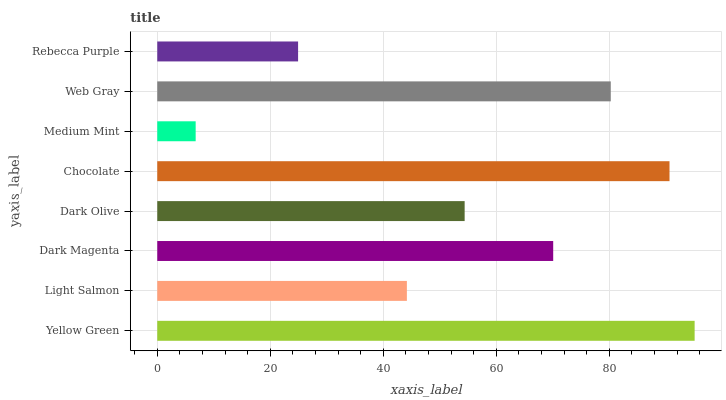Is Medium Mint the minimum?
Answer yes or no. Yes. Is Yellow Green the maximum?
Answer yes or no. Yes. Is Light Salmon the minimum?
Answer yes or no. No. Is Light Salmon the maximum?
Answer yes or no. No. Is Yellow Green greater than Light Salmon?
Answer yes or no. Yes. Is Light Salmon less than Yellow Green?
Answer yes or no. Yes. Is Light Salmon greater than Yellow Green?
Answer yes or no. No. Is Yellow Green less than Light Salmon?
Answer yes or no. No. Is Dark Magenta the high median?
Answer yes or no. Yes. Is Dark Olive the low median?
Answer yes or no. Yes. Is Light Salmon the high median?
Answer yes or no. No. Is Yellow Green the low median?
Answer yes or no. No. 